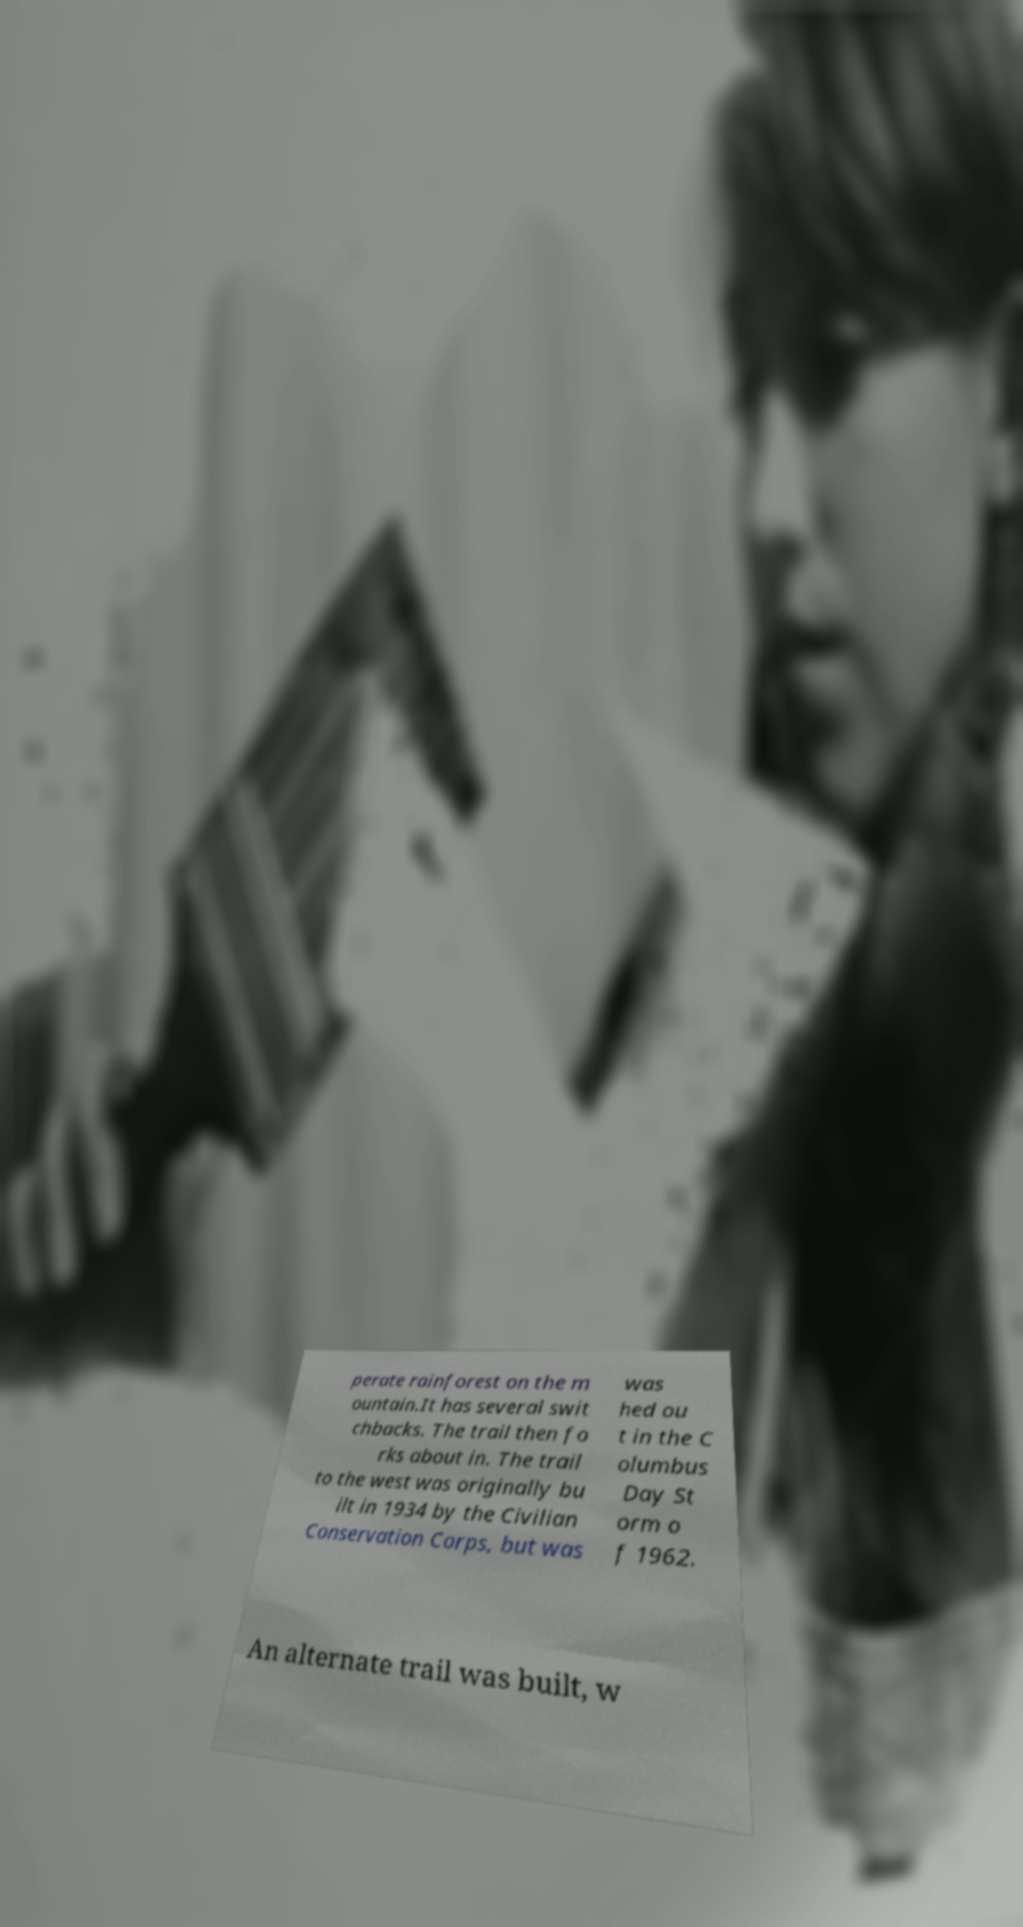Can you accurately transcribe the text from the provided image for me? perate rainforest on the m ountain.It has several swit chbacks. The trail then fo rks about in. The trail to the west was originally bu ilt in 1934 by the Civilian Conservation Corps, but was was hed ou t in the C olumbus Day St orm o f 1962. An alternate trail was built, w 